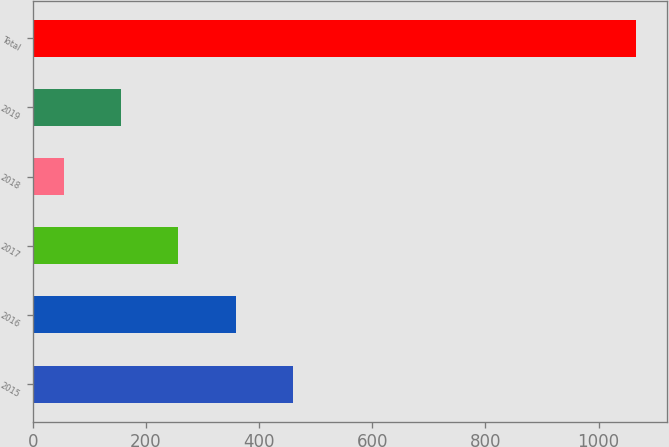<chart> <loc_0><loc_0><loc_500><loc_500><bar_chart><fcel>2015<fcel>2016<fcel>2017<fcel>2018<fcel>2019<fcel>Total<nl><fcel>459.8<fcel>358.6<fcel>257.4<fcel>55<fcel>156.2<fcel>1067<nl></chart> 